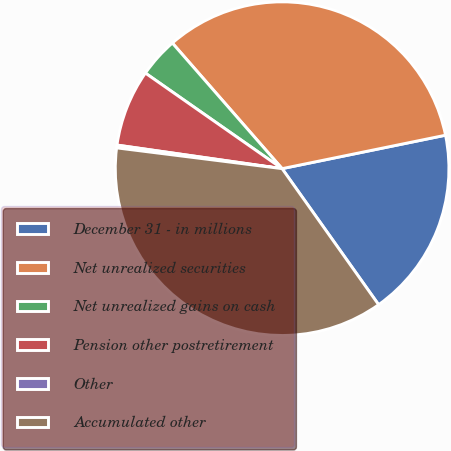<chart> <loc_0><loc_0><loc_500><loc_500><pie_chart><fcel>December 31 - in millions<fcel>Net unrealized securities<fcel>Net unrealized gains on cash<fcel>Pension other postretirement<fcel>Other<fcel>Accumulated other<nl><fcel>18.39%<fcel>33.21%<fcel>3.86%<fcel>7.45%<fcel>0.27%<fcel>36.8%<nl></chart> 